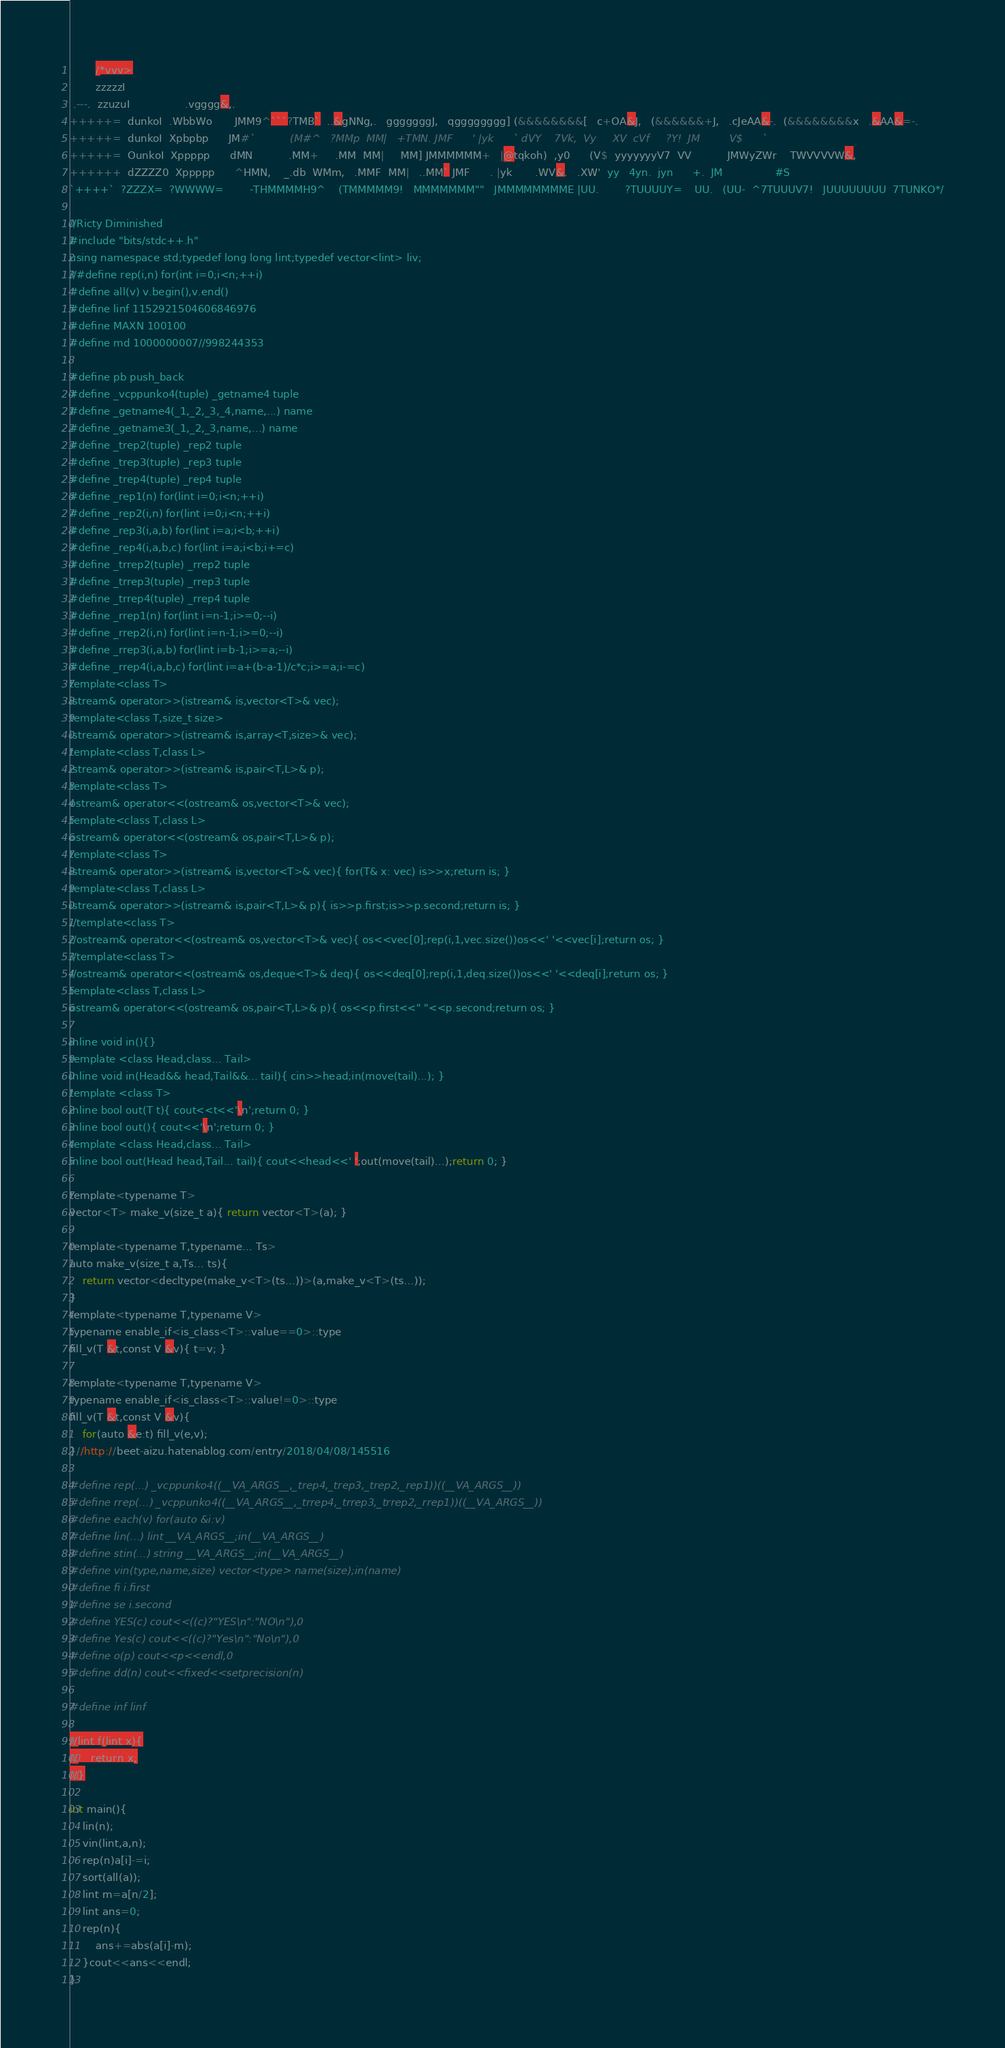<code> <loc_0><loc_0><loc_500><loc_500><_Awk_>

        /*vvv>
		zzzzzI
 .---.  zzuzuI                 .vgggg&,.
+++++=  dunkoI  .WbbWo       JMM9^```?TMB`  ..&gNNg,.   gggggggJ,   qgggggggg] (&&&&&&&&[   c+OA&J,   (&&&&&&+J,   .cJeAA&-.  (&&&&&&&&x   .&AA&=-.
+++++=  dunkoI  Xpbpbp      JM#`           (M#^   ?MMp  MM|   +TMN. JMF      ' |yk      ` dVY    7Vk,  Vy     XV  cVf     ?Y!  JM         V$      `
+++++=  OunkoI  Xppppp      dMN           .MM+     .MM  MM|     MM] JMMMMMM+   |@tqkoh)  ,y0      (V$  yyyyyyyV7  VV           JMWyZWr    TWVVVVW&,
++++++  dZZZZ0  Xppppp      ^HMN,    _.db  WMm,   .MMF  MM|   ..MM` JMF      . |yk       .WV&.   .XW'  yy   4yn.  jyn      +.  JM                #S
`++++`  ?ZZZX=  ?WWWW=        -THMMMMH9^    (TMMMMM9!   MMMMMMM""   JMMMMMMMME |UU.        ?TUUUUY=    UU.   (UU-  ^7TUUUV7!   JUUUUUUUU  7TUNKO*/

//Ricty Diminished
#include "bits/stdc++.h"
using namespace std;typedef long long lint;typedef vector<lint> liv;
//#define rep(i,n) for(int i=0;i<n;++i)
#define all(v) v.begin(),v.end()
#define linf 1152921504606846976
#define MAXN 100100
#define md 1000000007//998244353

#define pb push_back
#define _vcppunko4(tuple) _getname4 tuple
#define _getname4(_1,_2,_3,_4,name,...) name
#define _getname3(_1,_2,_3,name,...) name
#define _trep2(tuple) _rep2 tuple
#define _trep3(tuple) _rep3 tuple
#define _trep4(tuple) _rep4 tuple
#define _rep1(n) for(lint i=0;i<n;++i)
#define _rep2(i,n) for(lint i=0;i<n;++i)
#define _rep3(i,a,b) for(lint i=a;i<b;++i)
#define _rep4(i,a,b,c) for(lint i=a;i<b;i+=c)
#define _trrep2(tuple) _rrep2 tuple
#define _trrep3(tuple) _rrep3 tuple
#define _trrep4(tuple) _rrep4 tuple
#define _rrep1(n) for(lint i=n-1;i>=0;--i)
#define _rrep2(i,n) for(lint i=n-1;i>=0;--i)
#define _rrep3(i,a,b) for(lint i=b-1;i>=a;--i)
#define _rrep4(i,a,b,c) for(lint i=a+(b-a-1)/c*c;i>=a;i-=c)
template<class T>
istream& operator>>(istream& is,vector<T>& vec);
template<class T,size_t size>
istream& operator>>(istream& is,array<T,size>& vec);
template<class T,class L>
istream& operator>>(istream& is,pair<T,L>& p);
template<class T>
ostream& operator<<(ostream& os,vector<T>& vec);
template<class T,class L>
ostream& operator<<(ostream& os,pair<T,L>& p);
template<class T>
istream& operator>>(istream& is,vector<T>& vec){ for(T& x: vec) is>>x;return is; }
template<class T,class L>
istream& operator>>(istream& is,pair<T,L>& p){ is>>p.first;is>>p.second;return is; }
//template<class T>
//ostream& operator<<(ostream& os,vector<T>& vec){ os<<vec[0];rep(i,1,vec.size())os<<' '<<vec[i];return os; }
//template<class T>
//ostream& operator<<(ostream& os,deque<T>& deq){ os<<deq[0];rep(i,1,deq.size())os<<' '<<deq[i];return os; }
template<class T,class L>
ostream& operator<<(ostream& os,pair<T,L>& p){ os<<p.first<<" "<<p.second;return os; }

inline void in(){}
template <class Head,class... Tail>
inline void in(Head&& head,Tail&&... tail){ cin>>head;in(move(tail)...); }
template <class T>
inline bool out(T t){ cout<<t<<'\n';return 0; }
inline bool out(){ cout<<'\n';return 0; }
template <class Head,class... Tail>
inline bool out(Head head,Tail... tail){ cout<<head<<' ';out(move(tail)...);return 0; }

template<typename T>
vector<T> make_v(size_t a){ return vector<T>(a); }

template<typename T,typename... Ts>
auto make_v(size_t a,Ts... ts){
	return vector<decltype(make_v<T>(ts...))>(a,make_v<T>(ts...));
}
template<typename T,typename V>
typename enable_if<is_class<T>::value==0>::type
fill_v(T &t,const V &v){ t=v; }

template<typename T,typename V>
typename enable_if<is_class<T>::value!=0>::type
fill_v(T &t,const V &v){
	for(auto &e:t) fill_v(e,v);
}//http://beet-aizu.hatenablog.com/entry/2018/04/08/145516

#define rep(...) _vcppunko4((__VA_ARGS__,_trep4,_trep3,_trep2,_rep1))((__VA_ARGS__))
#define rrep(...) _vcppunko4((__VA_ARGS__,_trrep4,_trrep3,_trrep2,_rrep1))((__VA_ARGS__))
#define each(v) for(auto &i:v)
#define lin(...) lint __VA_ARGS__;in(__VA_ARGS__)
#define stin(...) string __VA_ARGS__;in(__VA_ARGS__)
#define vin(type,name,size) vector<type> name(size);in(name)
#define fi i.first
#define se i.second
#define YES(c) cout<<((c)?"YES\n":"NO\n"),0
#define Yes(c) cout<<((c)?"Yes\n":"No\n"),0
#define o(p) cout<<p<<endl,0
#define dd(n) cout<<fixed<<setprecision(n)

#define inf linf

//lint f(lint x){
//	return x;
//}

int main(){
	lin(n);
	vin(lint,a,n);
	rep(n)a[i]-=i;
	sort(all(a));
	lint m=a[n/2];
	lint ans=0;
	rep(n){
		ans+=abs(a[i]-m);
	}cout<<ans<<endl;
}</code> 